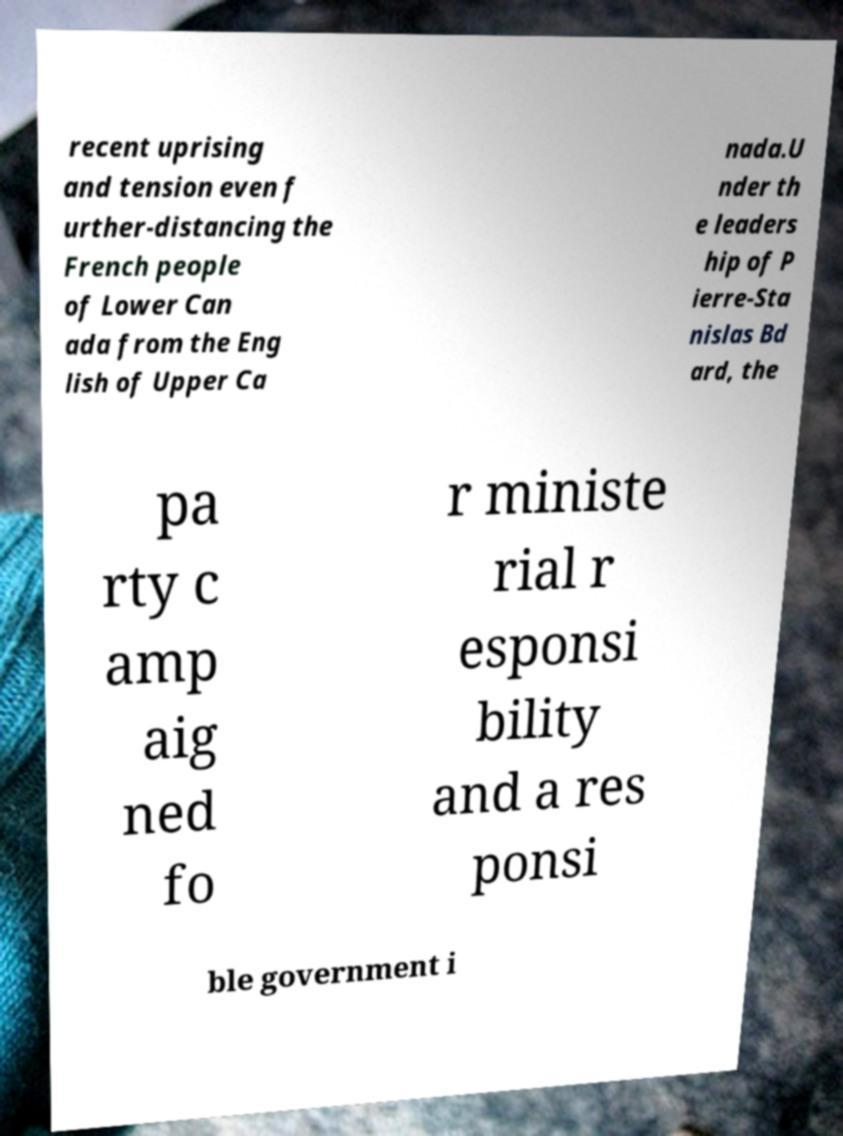Could you assist in decoding the text presented in this image and type it out clearly? recent uprising and tension even f urther-distancing the French people of Lower Can ada from the Eng lish of Upper Ca nada.U nder th e leaders hip of P ierre-Sta nislas Bd ard, the pa rty c amp aig ned fo r ministe rial r esponsi bility and a res ponsi ble government i 